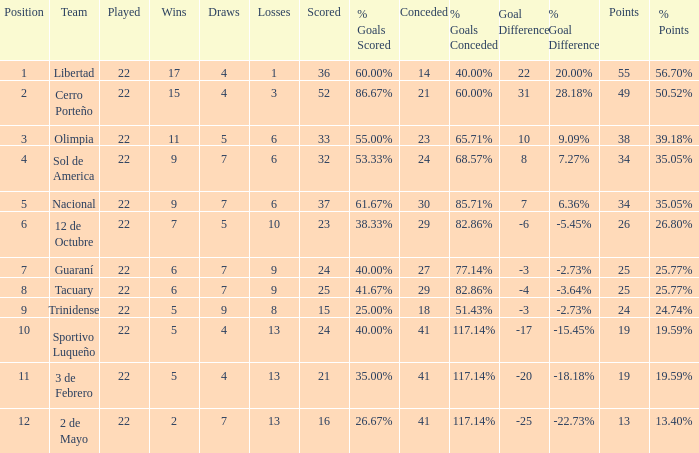What is the number of draws for the team with more than 8 losses and 13 points? 7.0. 